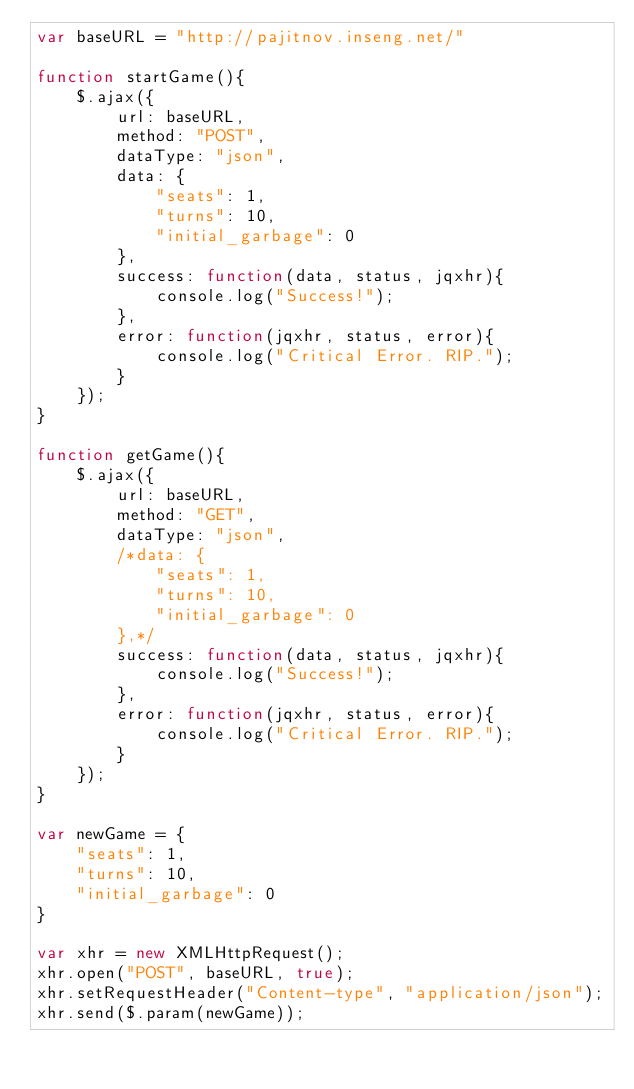<code> <loc_0><loc_0><loc_500><loc_500><_JavaScript_>var baseURL = "http://pajitnov.inseng.net/"

function startGame(){
	$.ajax({
		url: baseURL,
		method: "POST",
		dataType: "json",
		data: {
			"seats": 1,
			"turns": 10,
			"initial_garbage": 0
		},
		success: function(data, status, jqxhr){
			console.log("Success!");
		},
		error: function(jqxhr, status, error){
			console.log("Critical Error. RIP.");
		}
	});
}

function getGame(){
	$.ajax({
		url: baseURL,
		method: "GET",
		dataType: "json",
		/*data: {
			"seats": 1,
			"turns": 10,
			"initial_garbage": 0
		},*/
		success: function(data, status, jqxhr){
			console.log("Success!");
		},
		error: function(jqxhr, status, error){
			console.log("Critical Error. RIP.");
		}
	});
}

var newGame = {
	"seats": 1,
	"turns": 10,
	"initial_garbage": 0
}

var xhr = new XMLHttpRequest();
xhr.open("POST", baseURL, true);
xhr.setRequestHeader("Content-type", "application/json");
xhr.send($.param(newGame));
</code> 